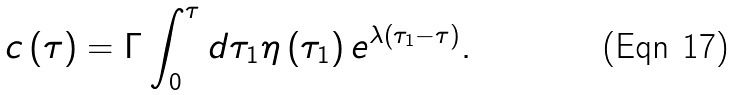Convert formula to latex. <formula><loc_0><loc_0><loc_500><loc_500>c \left ( \tau \right ) = \Gamma \int _ { 0 } ^ { \tau } d \tau _ { 1 } \eta \left ( \tau _ { 1 } \right ) e ^ { \lambda \left ( \tau _ { 1 } - \tau \right ) } .</formula> 